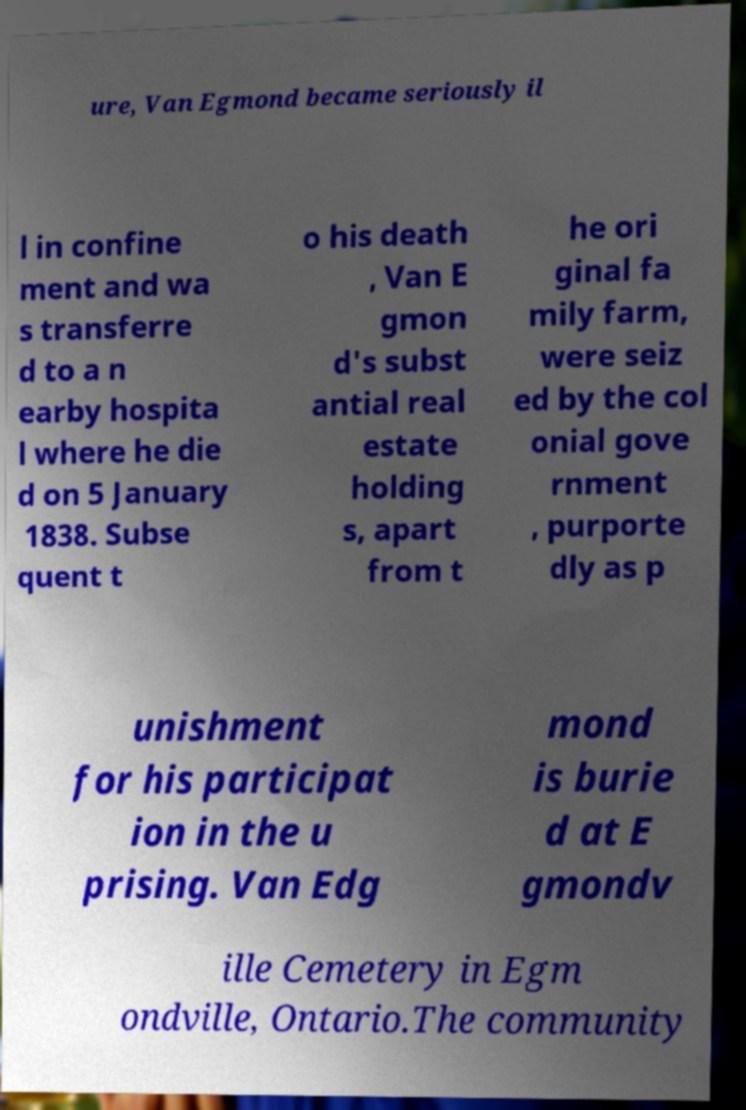Can you read and provide the text displayed in the image?This photo seems to have some interesting text. Can you extract and type it out for me? ure, Van Egmond became seriously il l in confine ment and wa s transferre d to a n earby hospita l where he die d on 5 January 1838. Subse quent t o his death , Van E gmon d's subst antial real estate holding s, apart from t he ori ginal fa mily farm, were seiz ed by the col onial gove rnment , purporte dly as p unishment for his participat ion in the u prising. Van Edg mond is burie d at E gmondv ille Cemetery in Egm ondville, Ontario.The community 